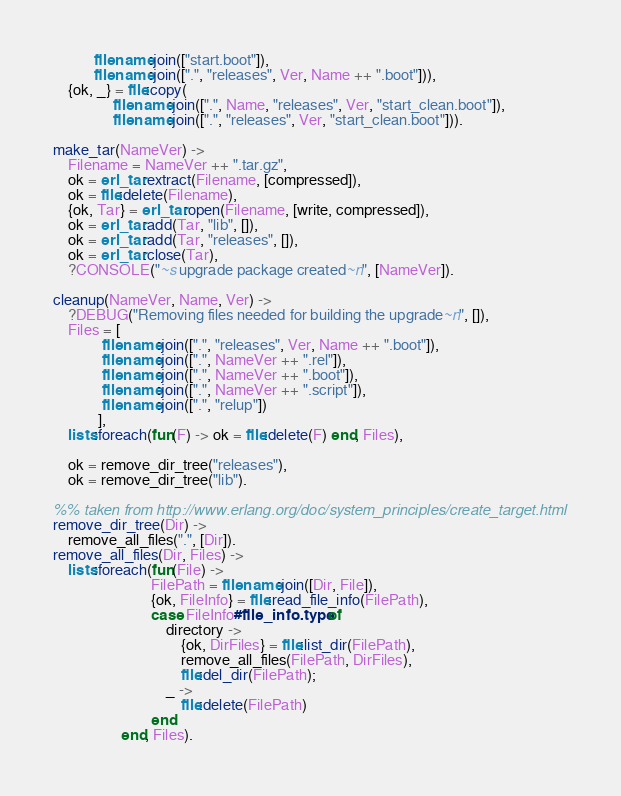Convert code to text. <code><loc_0><loc_0><loc_500><loc_500><_Erlang_>           filename:join(["start.boot"]),
           filename:join([".", "releases", Ver, Name ++ ".boot"])),
    {ok, _} = file:copy(
                filename:join([".", Name, "releases", Ver, "start_clean.boot"]),
                filename:join([".", "releases", Ver, "start_clean.boot"])).

make_tar(NameVer) ->
    Filename = NameVer ++ ".tar.gz",
    ok = erl_tar:extract(Filename, [compressed]),
    ok = file:delete(Filename),
    {ok, Tar} = erl_tar:open(Filename, [write, compressed]),
    ok = erl_tar:add(Tar, "lib", []),
    ok = erl_tar:add(Tar, "releases", []),
    ok = erl_tar:close(Tar),
    ?CONSOLE("~s upgrade package created~n", [NameVer]).

cleanup(NameVer, Name, Ver) ->
    ?DEBUG("Removing files needed for building the upgrade~n", []),
    Files = [
             filename:join([".", "releases", Ver, Name ++ ".boot"]),
             filename:join([".", NameVer ++ ".rel"]),
             filename:join([".", NameVer ++ ".boot"]),
             filename:join([".", NameVer ++ ".script"]),
             filename:join([".", "relup"])
            ],
    lists:foreach(fun(F) -> ok = file:delete(F) end, Files),

    ok = remove_dir_tree("releases"),
    ok = remove_dir_tree("lib").

%% taken from http://www.erlang.org/doc/system_principles/create_target.html
remove_dir_tree(Dir) ->
    remove_all_files(".", [Dir]).
remove_all_files(Dir, Files) ->
    lists:foreach(fun(File) ->
                          FilePath = filename:join([Dir, File]),
                          {ok, FileInfo} = file:read_file_info(FilePath),
                          case FileInfo#file_info.type of
                              directory ->
                                  {ok, DirFiles} = file:list_dir(FilePath),
                                  remove_all_files(FilePath, DirFiles),
                                  file:del_dir(FilePath);
                              _ ->
                                  file:delete(FilePath)
                          end
                  end, Files).
</code> 